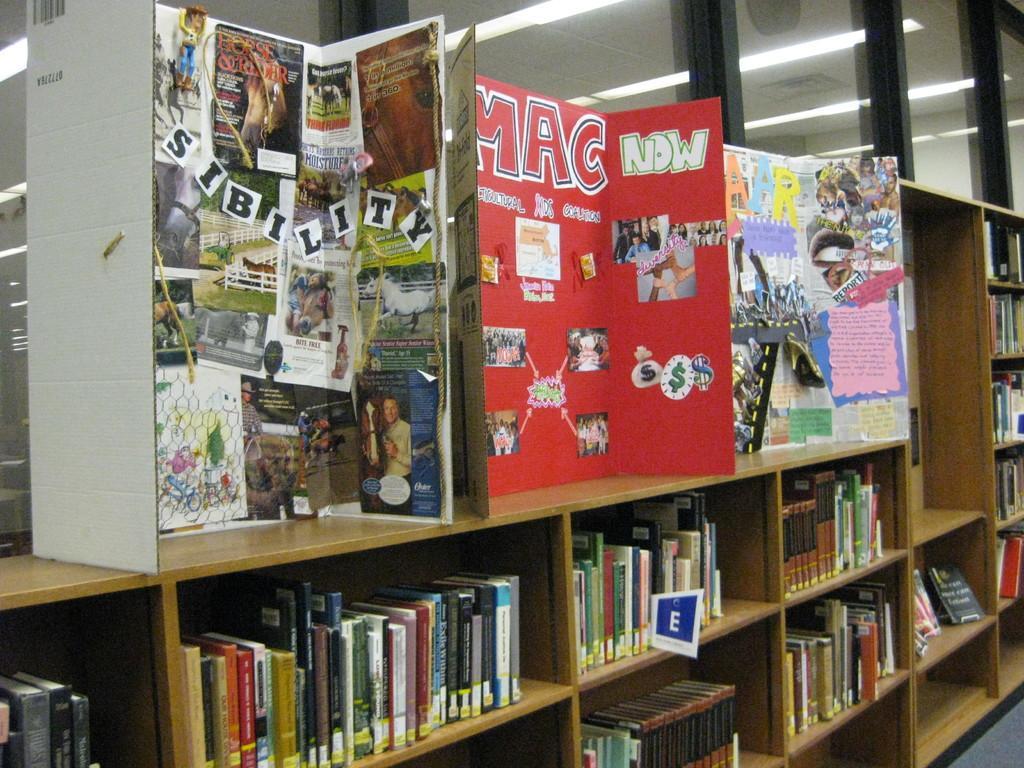In one or two sentences, can you explain what this image depicts? In this picture we can see the reflection of lights on the glasses. We can see the posters with some information and we can see the boards. We can see the books arranged in the wooden racks and we can see the floor. 